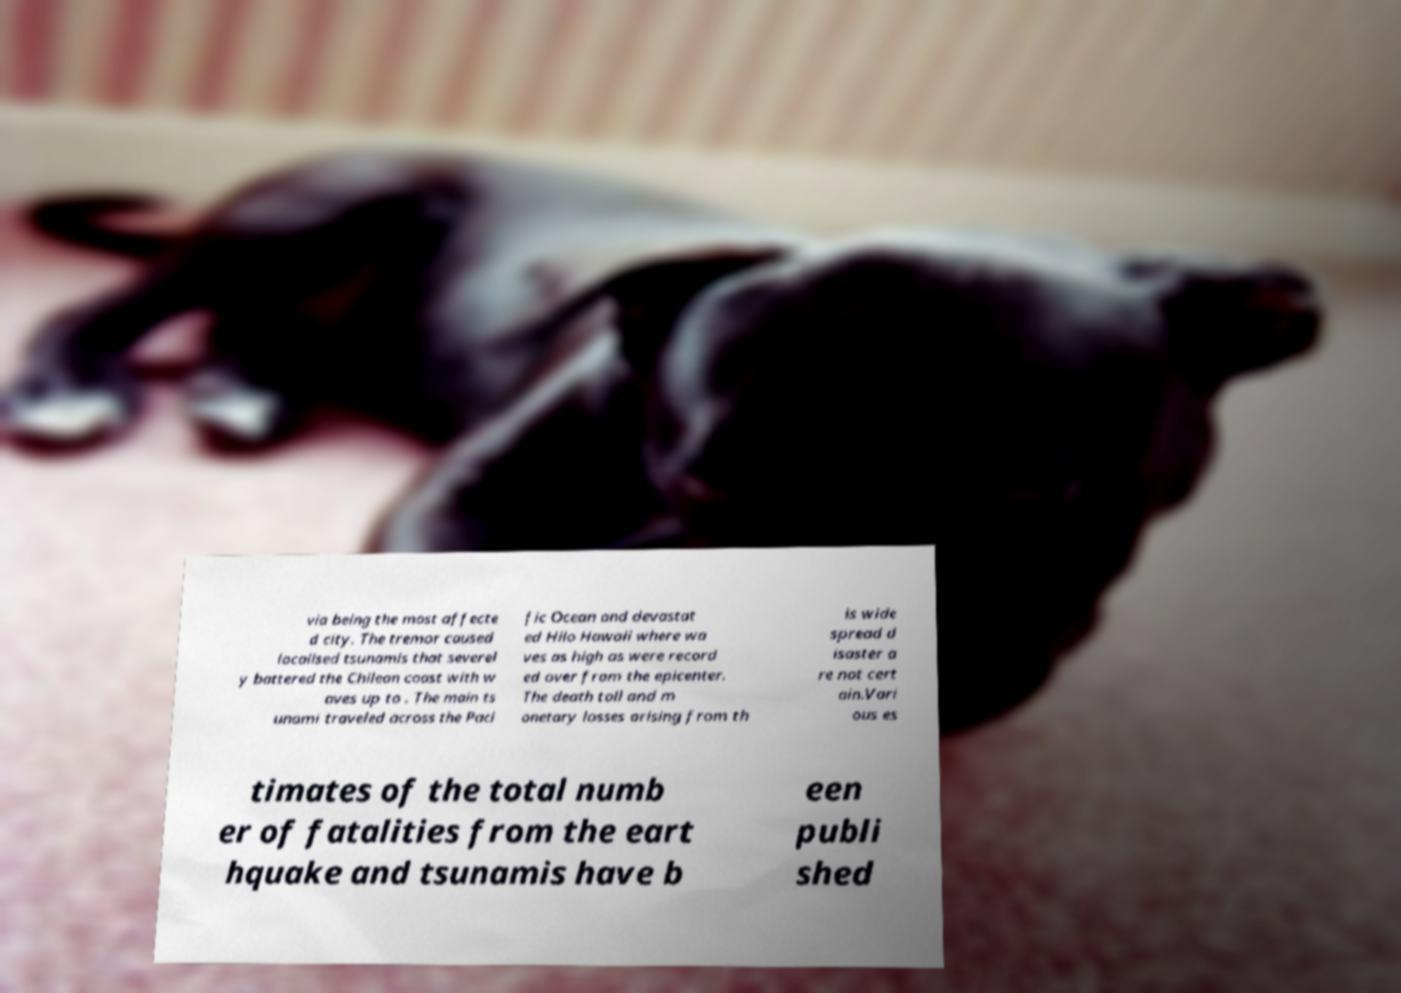Please read and relay the text visible in this image. What does it say? via being the most affecte d city. The tremor caused localised tsunamis that severel y battered the Chilean coast with w aves up to . The main ts unami traveled across the Paci fic Ocean and devastat ed Hilo Hawaii where wa ves as high as were record ed over from the epicenter. The death toll and m onetary losses arising from th is wide spread d isaster a re not cert ain.Vari ous es timates of the total numb er of fatalities from the eart hquake and tsunamis have b een publi shed 